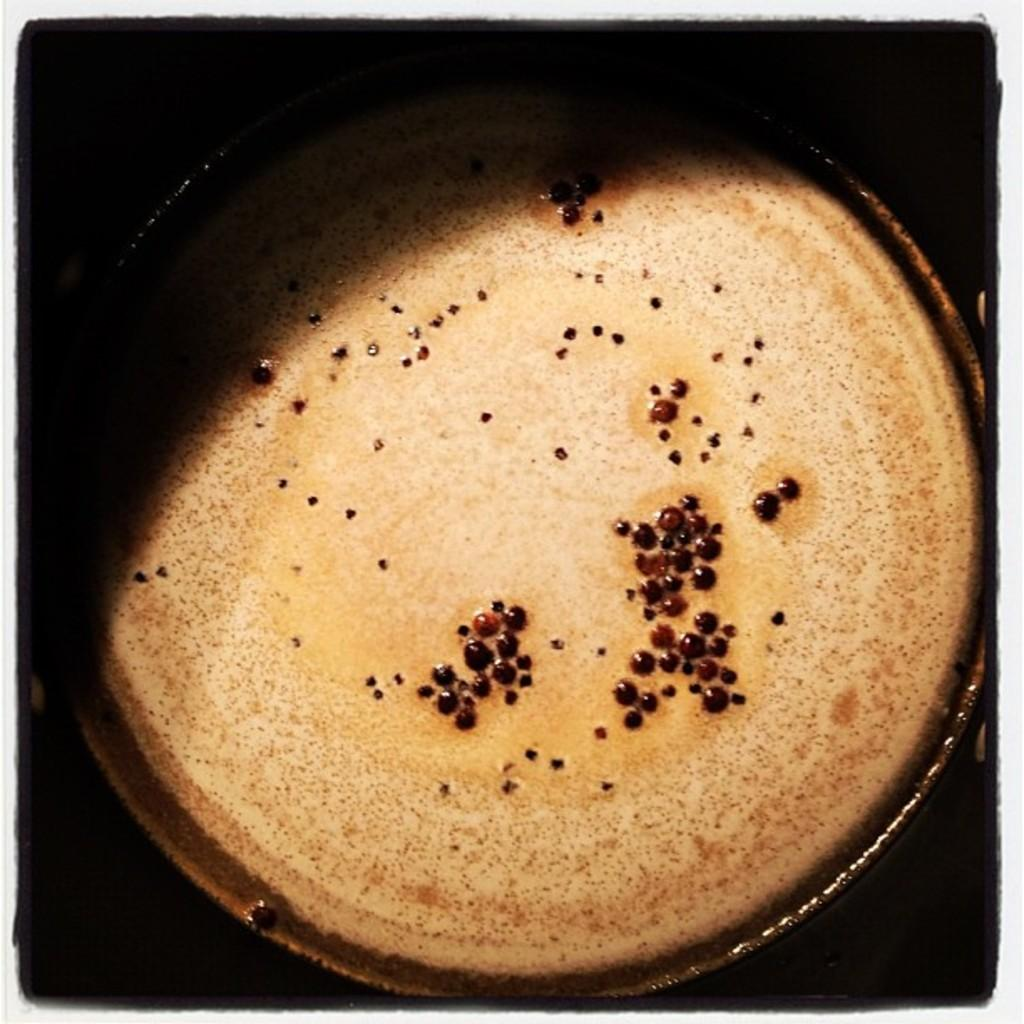What is in the cup that is visible in the image? There is a cup in the image, and it contains coffee. What is the color of the coffee in the cup? The coffee is brown in color. How would you describe the background of the image? The background of the image is dark. What type of coil is present in the image? There is no coil present in the image. Can you tell me the name of the son in the image? There is no person, let alone a son, present in the image. 